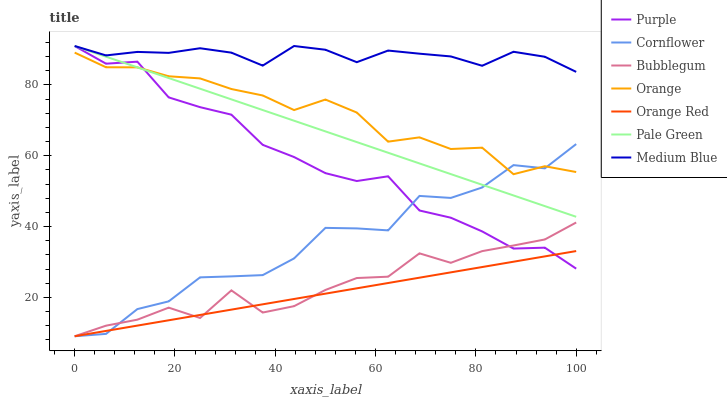Does Purple have the minimum area under the curve?
Answer yes or no. No. Does Purple have the maximum area under the curve?
Answer yes or no. No. Is Purple the smoothest?
Answer yes or no. No. Is Purple the roughest?
Answer yes or no. No. Does Purple have the lowest value?
Answer yes or no. No. Does Bubblegum have the highest value?
Answer yes or no. No. Is Bubblegum less than Pale Green?
Answer yes or no. Yes. Is Medium Blue greater than Orange?
Answer yes or no. Yes. Does Bubblegum intersect Pale Green?
Answer yes or no. No. 